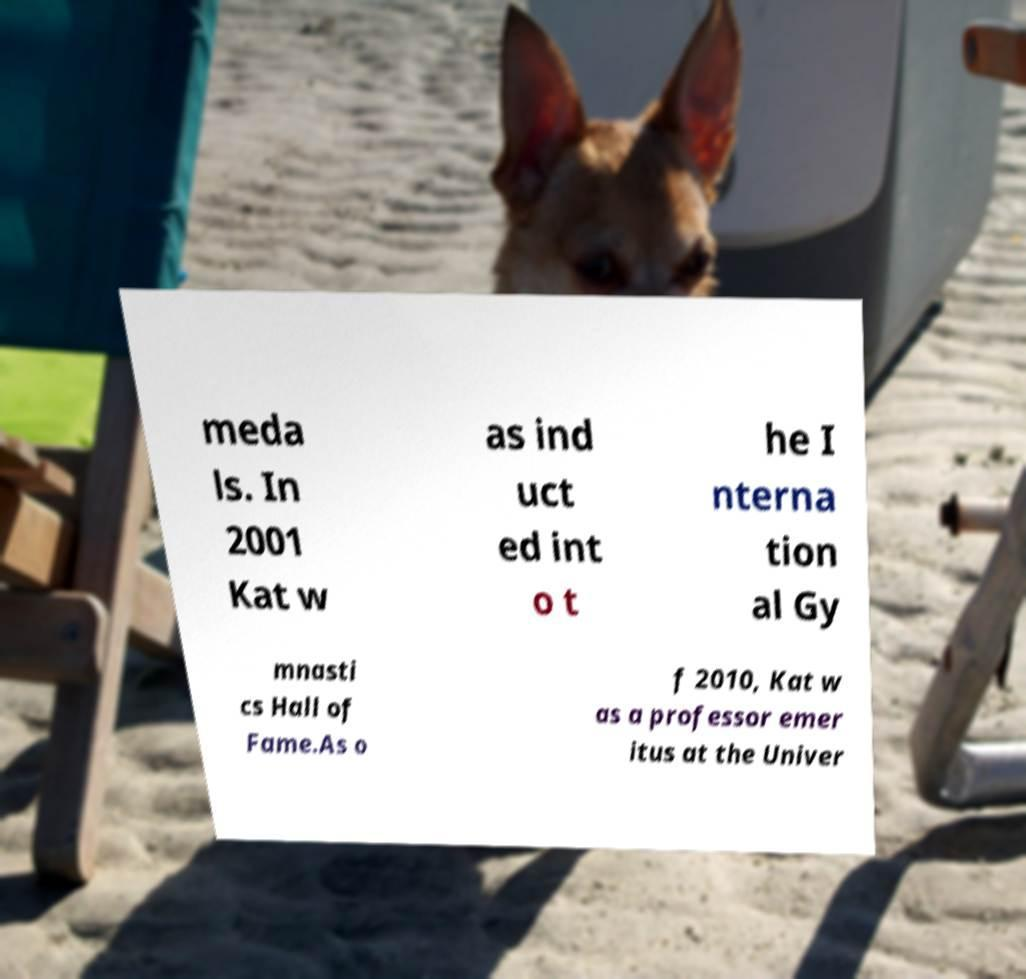Please identify and transcribe the text found in this image. meda ls. In 2001 Kat w as ind uct ed int o t he I nterna tion al Gy mnasti cs Hall of Fame.As o f 2010, Kat w as a professor emer itus at the Univer 